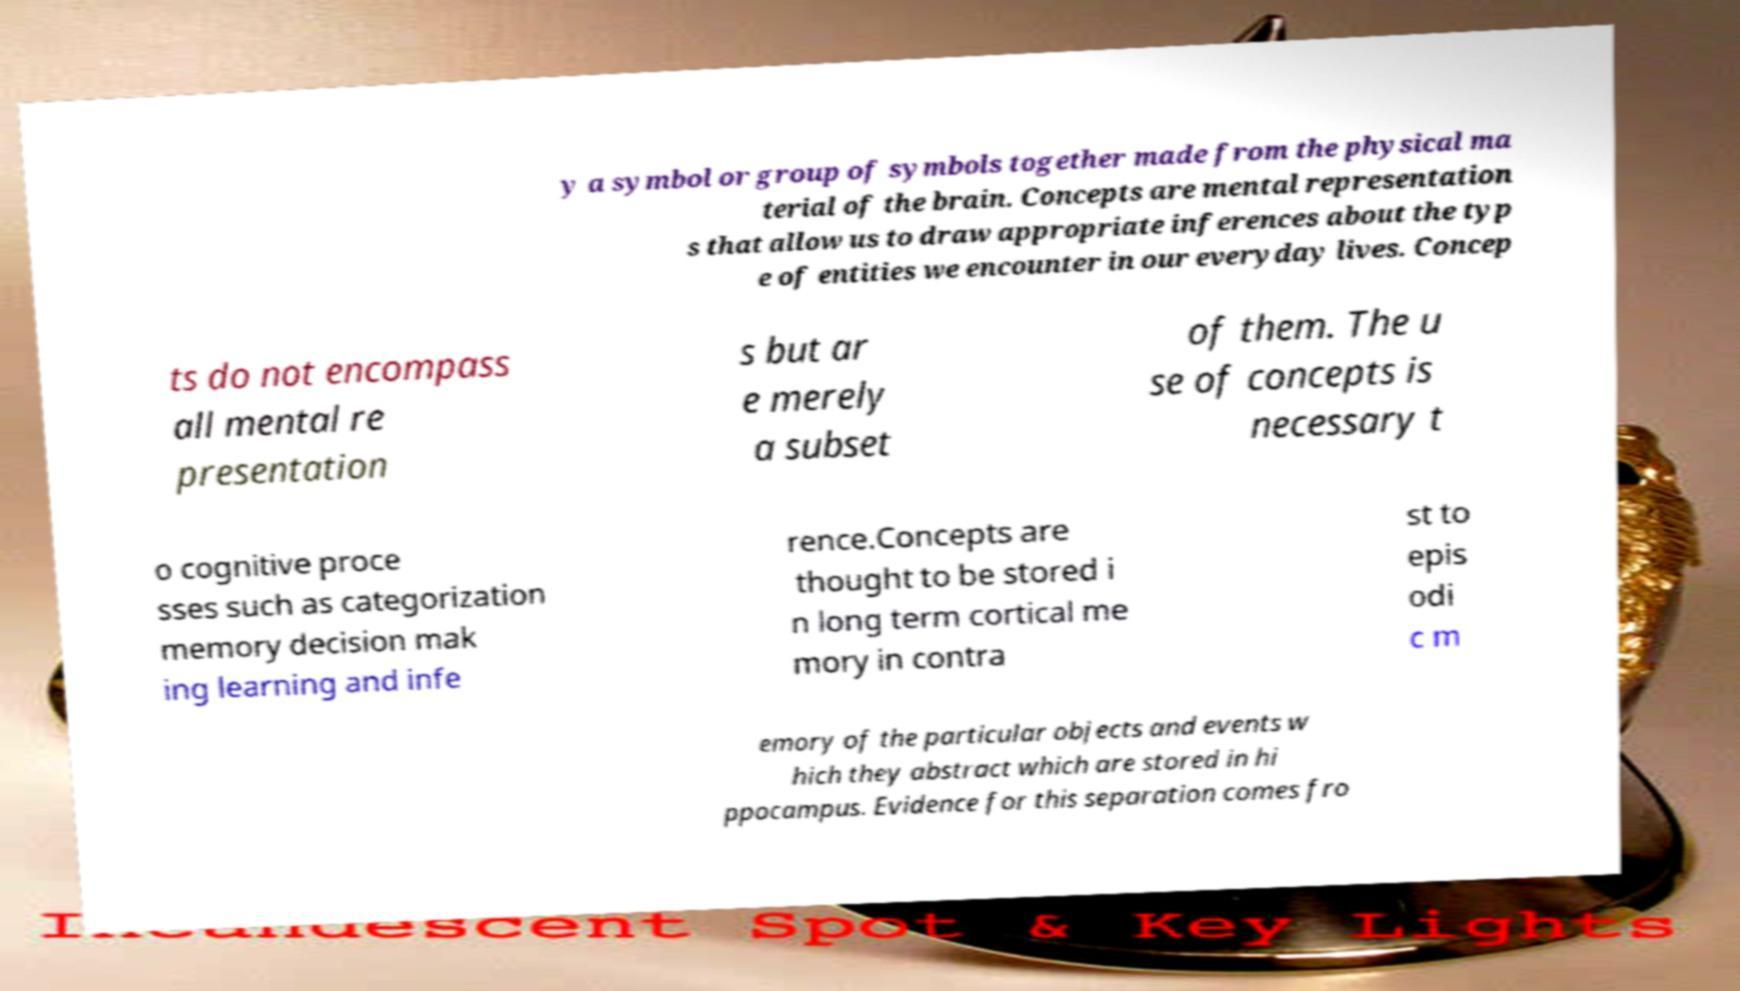There's text embedded in this image that I need extracted. Can you transcribe it verbatim? y a symbol or group of symbols together made from the physical ma terial of the brain. Concepts are mental representation s that allow us to draw appropriate inferences about the typ e of entities we encounter in our everyday lives. Concep ts do not encompass all mental re presentation s but ar e merely a subset of them. The u se of concepts is necessary t o cognitive proce sses such as categorization memory decision mak ing learning and infe rence.Concepts are thought to be stored i n long term cortical me mory in contra st to epis odi c m emory of the particular objects and events w hich they abstract which are stored in hi ppocampus. Evidence for this separation comes fro 